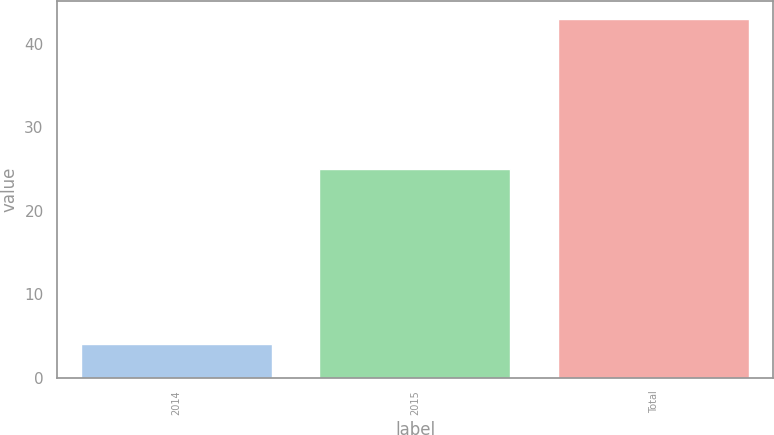Convert chart. <chart><loc_0><loc_0><loc_500><loc_500><bar_chart><fcel>2014<fcel>2015<fcel>Total<nl><fcel>4<fcel>25<fcel>43<nl></chart> 